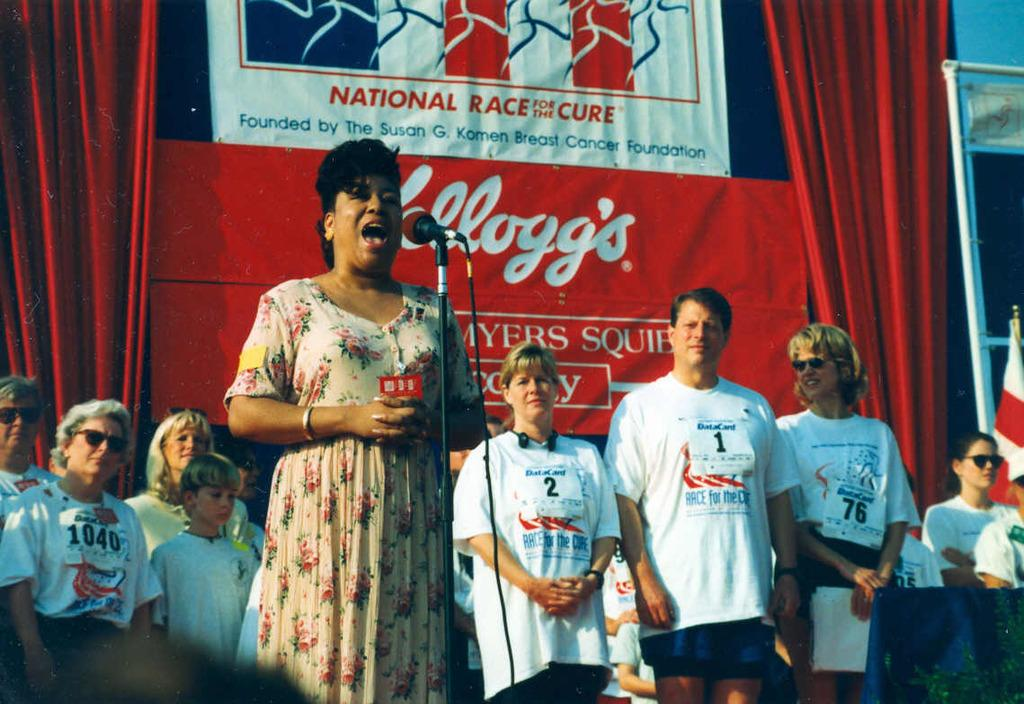<image>
Relay a brief, clear account of the picture shown. A woman speaks into a microphone in front of other people at a National Race For The Cure event. 